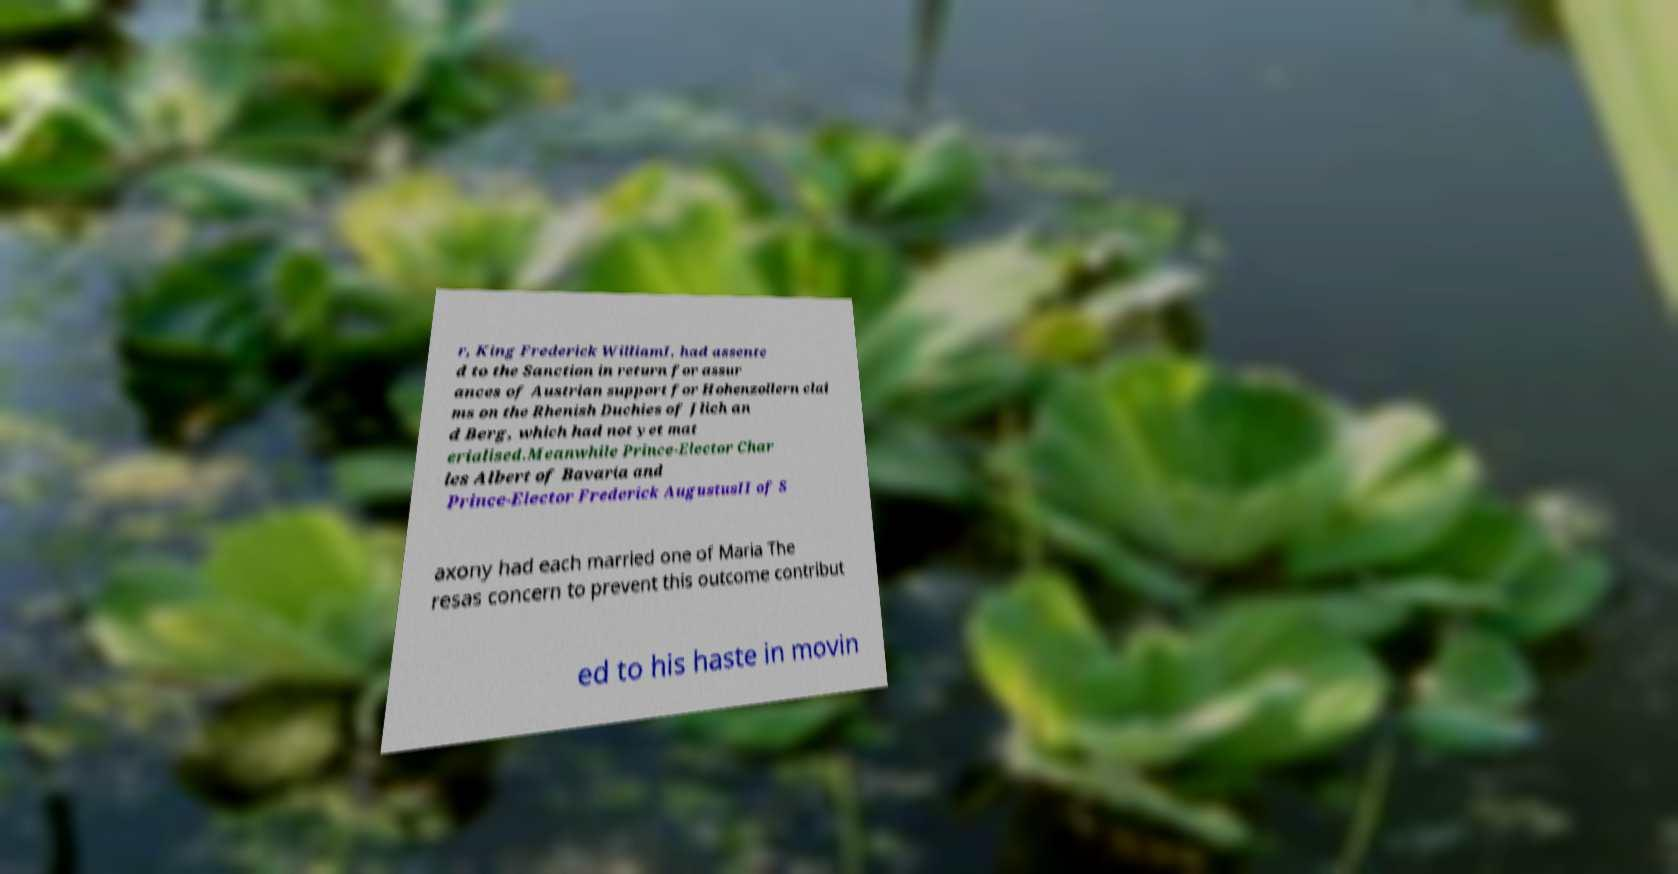Can you accurately transcribe the text from the provided image for me? r, King Frederick WilliamI, had assente d to the Sanction in return for assur ances of Austrian support for Hohenzollern clai ms on the Rhenish Duchies of Jlich an d Berg, which had not yet mat erialised.Meanwhile Prince-Elector Char les Albert of Bavaria and Prince-Elector Frederick AugustusII of S axony had each married one of Maria The resas concern to prevent this outcome contribut ed to his haste in movin 